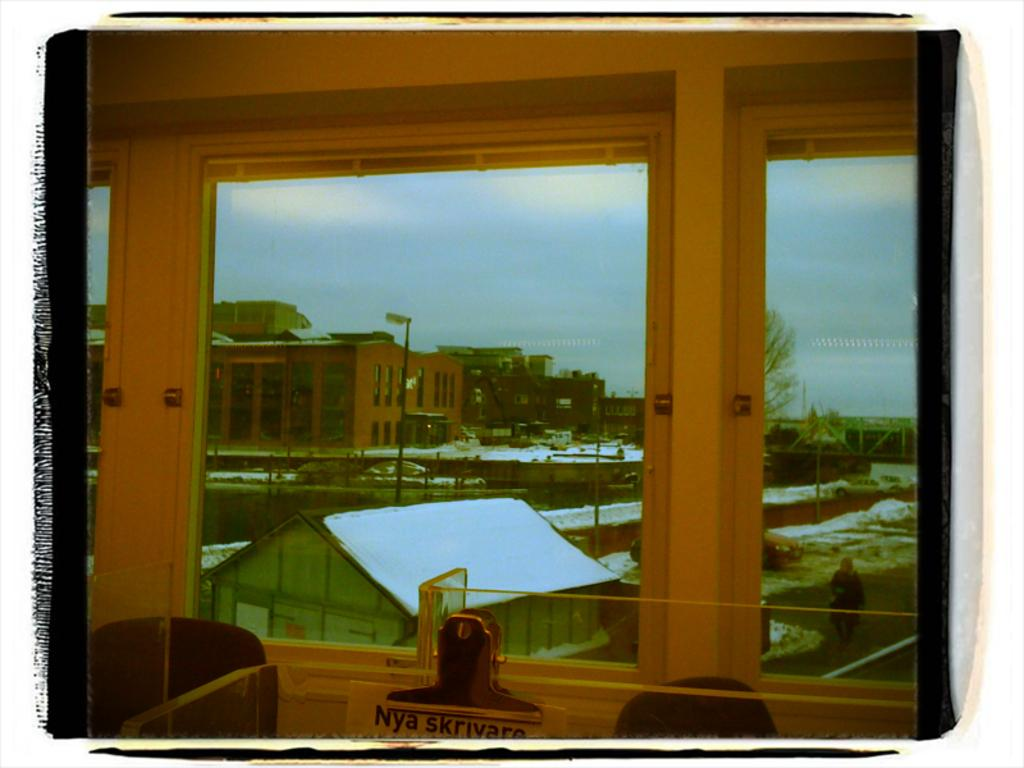What type of structure can be seen in the image? There is a glass window in the image. What can be seen in the distance behind the window? Buildings, a light-pole, trees, and vehicles on the road are visible in the background. What is the color of the sky in the image? The sky is blue and white and white in color. Can you tell me how many ducks are swimming in the water near the light-pole? There are no ducks present in the image; it features a glass window with a background of buildings, a light-pole, trees, and vehicles on the road. 